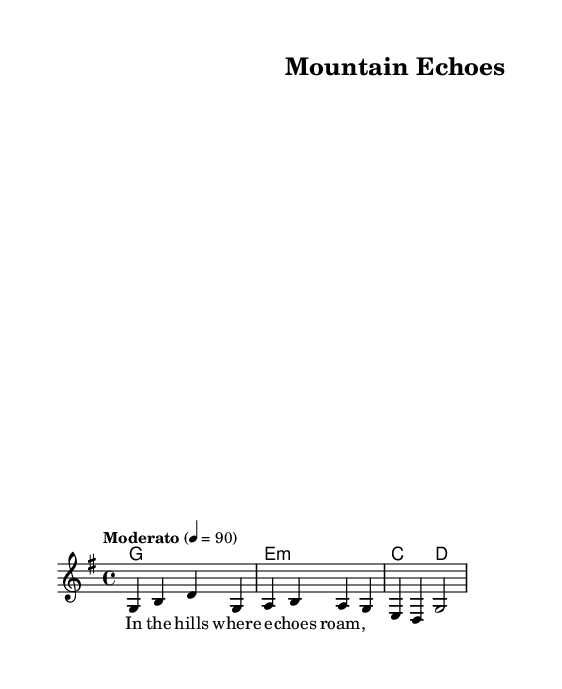What is the key signature of this music? The key signature is G major, which has one sharp (F#).
Answer: G major What is the time signature of this music? The time signature is 4/4, indicating four beats per measure with a quarter note getting one beat.
Answer: 4/4 What is the tempo marking for this piece? The tempo marking is "Moderato," which suggests a moderate speed.
Answer: Moderato How many measures are in the melody section? There are three measures visible in the melody section. Each vertical line indicates a separate measure.
Answer: 3 What is the first note of the melody? The first note of the melody is G, as indicated by the first note in the staff.
Answer: G What type of harmony is used in this piece? The harmony consists of simple chord progressions, specifically major and minor chords based on the key signature.
Answer: Major and minor What lyrical theme is suggested by the first line of the verse? The first line suggests themes of nature and solitude, as it refers to "the hills where echoes roam."
Answer: Nature and solitude 